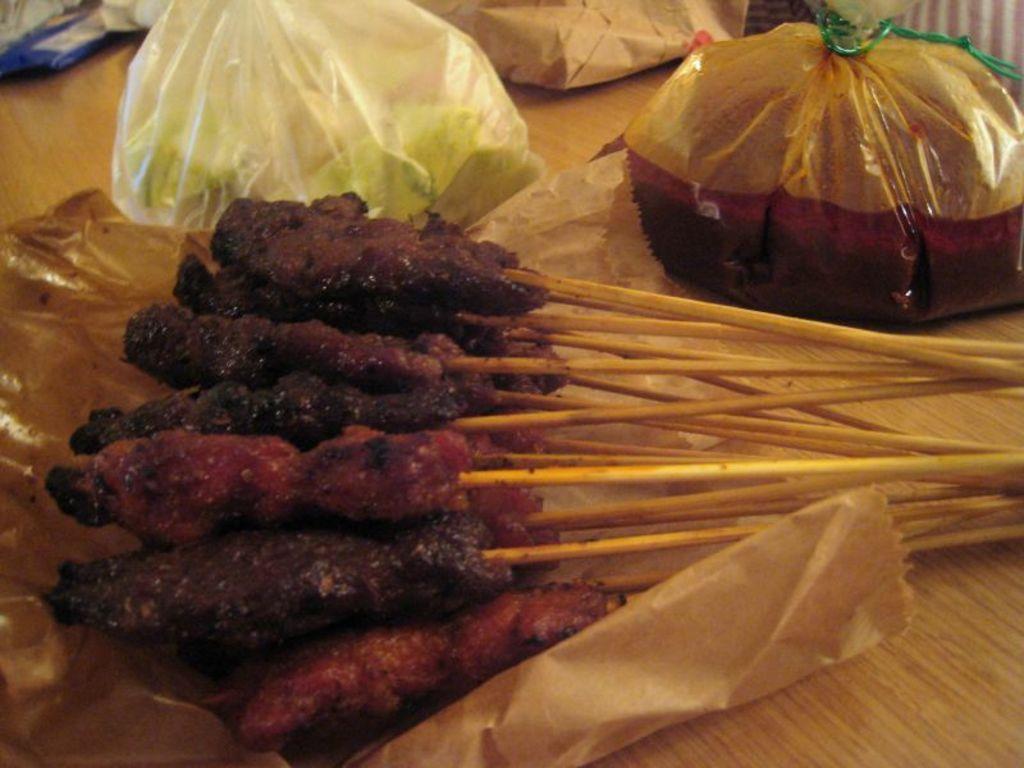Could you give a brief overview of what you see in this image? In the image there are food items,covers,meat sticks on a wooden table. 